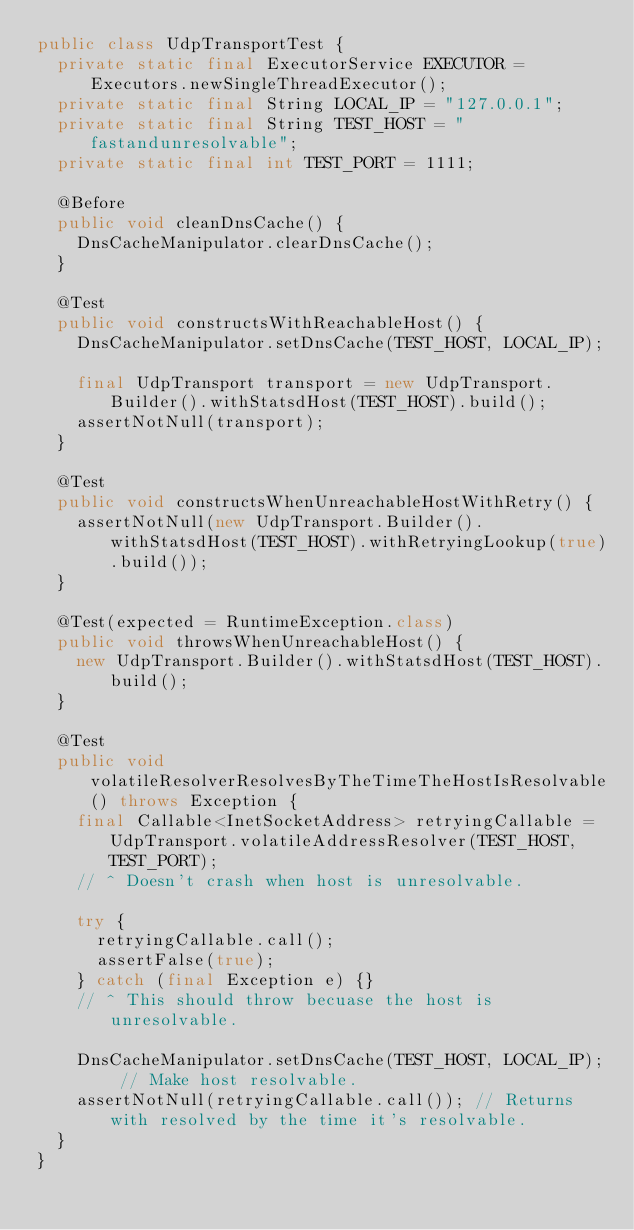Convert code to text. <code><loc_0><loc_0><loc_500><loc_500><_Java_>public class UdpTransportTest {
  private static final ExecutorService EXECUTOR = Executors.newSingleThreadExecutor();
  private static final String LOCAL_IP = "127.0.0.1";
  private static final String TEST_HOST = "fastandunresolvable";
  private static final int TEST_PORT = 1111;

  @Before
  public void cleanDnsCache() {
    DnsCacheManipulator.clearDnsCache();
  }

  @Test
  public void constructsWithReachableHost() {
    DnsCacheManipulator.setDnsCache(TEST_HOST, LOCAL_IP);

    final UdpTransport transport = new UdpTransport.Builder().withStatsdHost(TEST_HOST).build();
    assertNotNull(transport);
  }

  @Test
  public void constructsWhenUnreachableHostWithRetry() {
    assertNotNull(new UdpTransport.Builder().withStatsdHost(TEST_HOST).withRetryingLookup(true).build());
  }

  @Test(expected = RuntimeException.class)
  public void throwsWhenUnreachableHost() {
    new UdpTransport.Builder().withStatsdHost(TEST_HOST).build();
  }

  @Test
  public void volatileResolverResolvesByTheTimeTheHostIsResolvable() throws Exception {
    final Callable<InetSocketAddress> retryingCallable = UdpTransport.volatileAddressResolver(TEST_HOST, TEST_PORT);
    // ^ Doesn't crash when host is unresolvable.

    try {
      retryingCallable.call();
      assertFalse(true);
    } catch (final Exception e) {}
    // ^ This should throw becuase the host is unresolvable.

    DnsCacheManipulator.setDnsCache(TEST_HOST, LOCAL_IP); // Make host resolvable.
    assertNotNull(retryingCallable.call()); // Returns with resolved by the time it's resolvable.
  }
}
</code> 